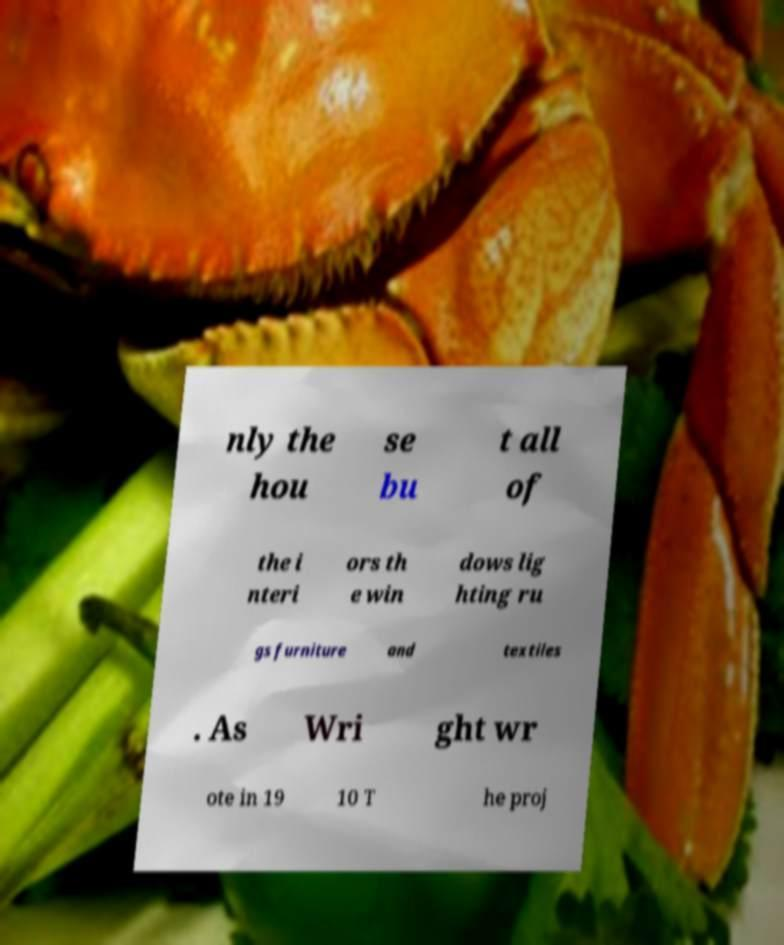Could you assist in decoding the text presented in this image and type it out clearly? nly the hou se bu t all of the i nteri ors th e win dows lig hting ru gs furniture and textiles . As Wri ght wr ote in 19 10 T he proj 